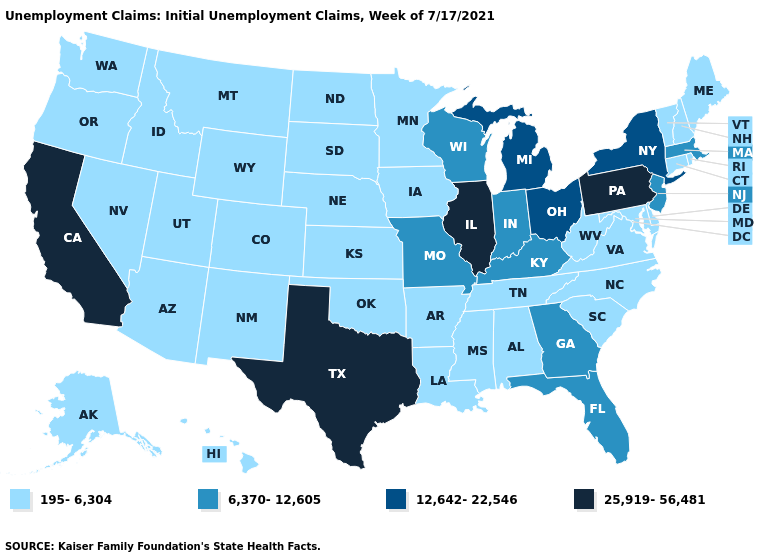Name the states that have a value in the range 12,642-22,546?
Write a very short answer. Michigan, New York, Ohio. Name the states that have a value in the range 12,642-22,546?
Give a very brief answer. Michigan, New York, Ohio. What is the highest value in the South ?
Concise answer only. 25,919-56,481. Name the states that have a value in the range 6,370-12,605?
Quick response, please. Florida, Georgia, Indiana, Kentucky, Massachusetts, Missouri, New Jersey, Wisconsin. Does the map have missing data?
Answer briefly. No. Which states have the lowest value in the South?
Keep it brief. Alabama, Arkansas, Delaware, Louisiana, Maryland, Mississippi, North Carolina, Oklahoma, South Carolina, Tennessee, Virginia, West Virginia. Is the legend a continuous bar?
Concise answer only. No. Does New York have the highest value in the Northeast?
Write a very short answer. No. Does the map have missing data?
Answer briefly. No. Name the states that have a value in the range 25,919-56,481?
Give a very brief answer. California, Illinois, Pennsylvania, Texas. What is the lowest value in states that border Nebraska?
Keep it brief. 195-6,304. What is the highest value in the USA?
Concise answer only. 25,919-56,481. Does Kentucky have the lowest value in the USA?
Give a very brief answer. No. 